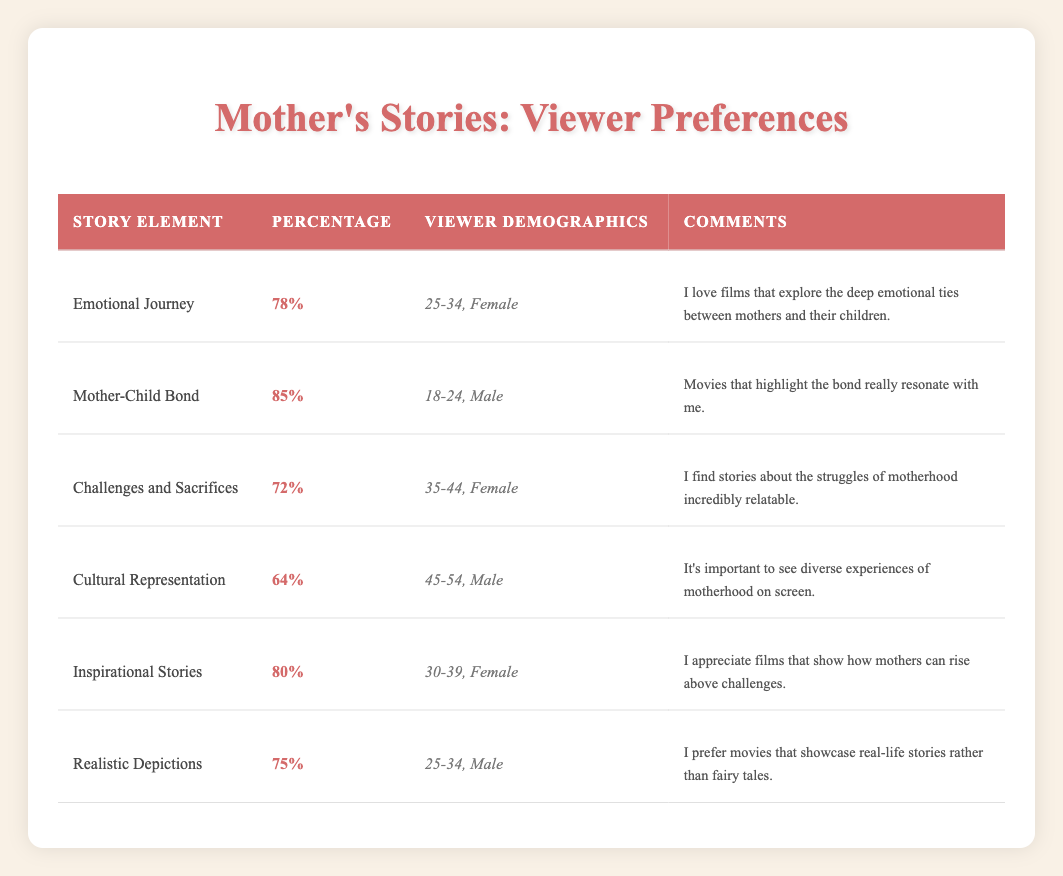What story element has the highest percentage preference among viewers? The table shows that "Mother-Child Bond" has the highest percentage at 85%.
Answer: Mother-Child Bond Which demographic preferred "Cultural Representation"? The "Cultural Representation" story element is preferred by viewers aged 45-54 and identifies as Male.
Answer: 45-54, Male What is the difference in percentage preference between "Emotional Journey" and "Challenges and Sacrifices"? "Emotional Journey" has a percentage of 78% and "Challenges and Sacrifices" has a percentage of 72%. The difference is 78% - 72% = 6%.
Answer: 6% Did more viewers prefer "Inspirational Stories" or "Realistic Depictions"? "Inspirational Stories" is preferred by 80% of viewers while "Realistic Depictions" is preferred by 75% of viewers. Therefore, more viewers preferred "Inspirational Stories".
Answer: Yes What percentage of viewers, on average, liked "Challenges and Sacrifices" and "Cultural Representation"? The percentages for "Challenges and Sacrifices" and "Cultural Representation" are 72% and 64%, respectively. The average is (72% + 64%)/2 = 68%.
Answer: 68% 